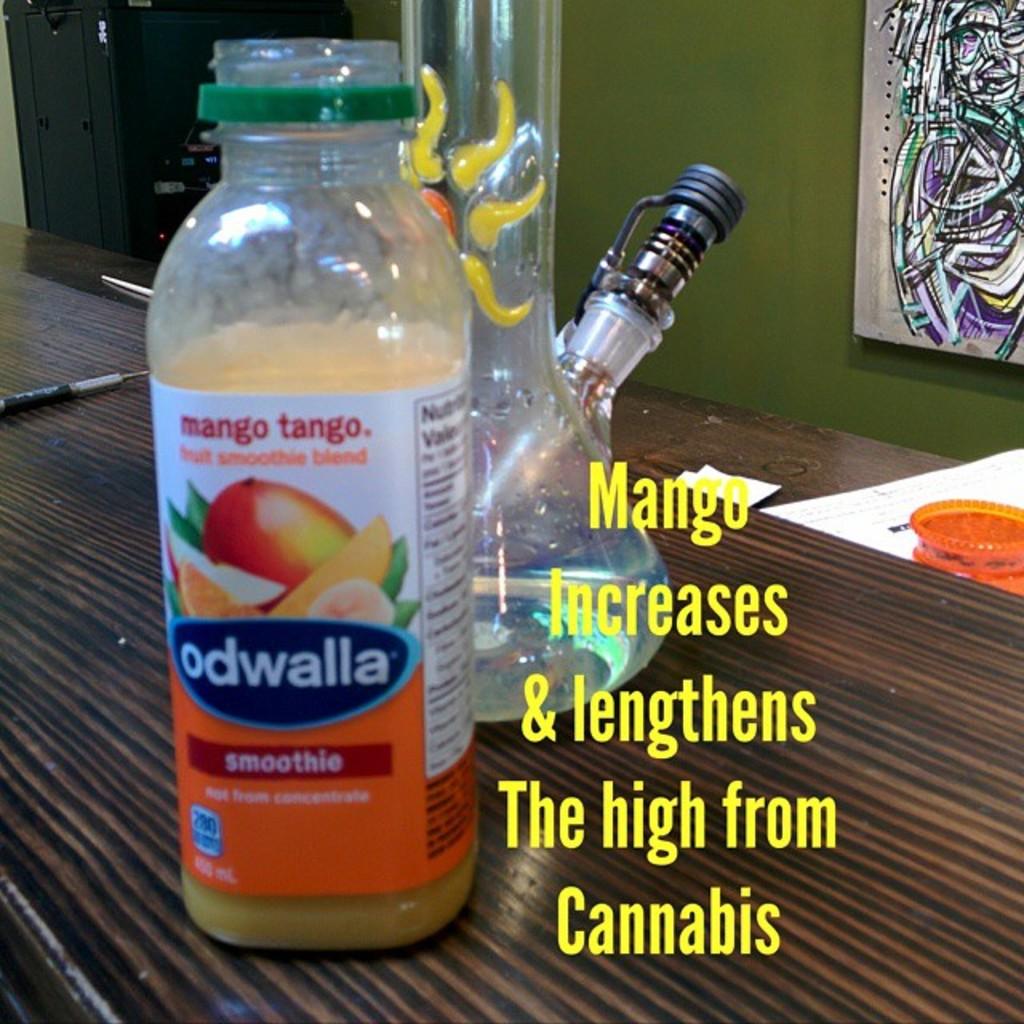What brand of smoothie is this?
Your answer should be compact. Odwalla. 